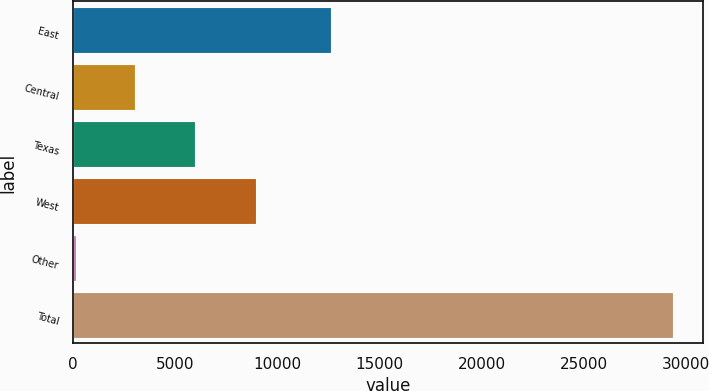Convert chart to OTSL. <chart><loc_0><loc_0><loc_500><loc_500><bar_chart><fcel>East<fcel>Central<fcel>Texas<fcel>West<fcel>Other<fcel>Total<nl><fcel>12625<fcel>3050.1<fcel>5977.2<fcel>8971<fcel>123<fcel>29394<nl></chart> 